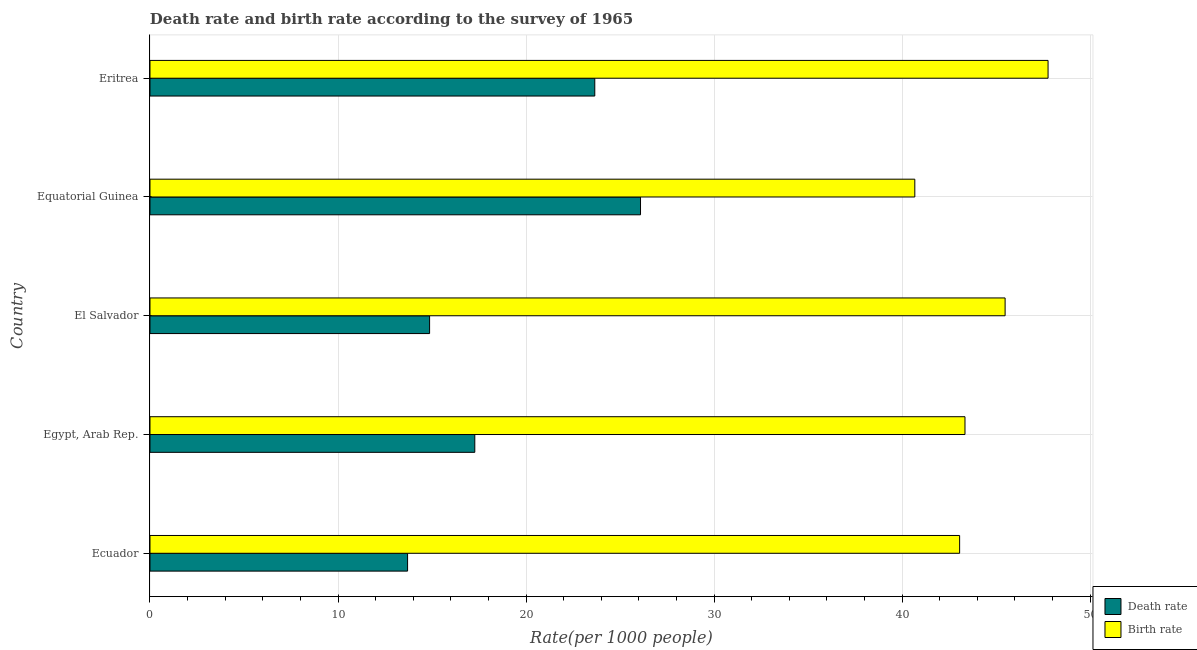What is the label of the 4th group of bars from the top?
Make the answer very short. Egypt, Arab Rep. In how many cases, is the number of bars for a given country not equal to the number of legend labels?
Make the answer very short. 0. What is the birth rate in Ecuador?
Keep it short and to the point. 43.06. Across all countries, what is the maximum death rate?
Make the answer very short. 26.09. Across all countries, what is the minimum death rate?
Your answer should be compact. 13.7. In which country was the birth rate maximum?
Ensure brevity in your answer.  Eritrea. In which country was the death rate minimum?
Offer a very short reply. Ecuador. What is the total death rate in the graph?
Provide a short and direct response. 95.59. What is the difference between the birth rate in Egypt, Arab Rep. and that in Eritrea?
Your response must be concise. -4.42. What is the difference between the birth rate in Ecuador and the death rate in Eritrea?
Your response must be concise. 19.4. What is the average death rate per country?
Ensure brevity in your answer.  19.12. What is the difference between the birth rate and death rate in El Salvador?
Offer a terse response. 30.61. In how many countries, is the death rate greater than 40 ?
Offer a very short reply. 0. What is the ratio of the birth rate in Equatorial Guinea to that in Eritrea?
Your response must be concise. 0.85. What is the difference between the highest and the second highest birth rate?
Your response must be concise. 2.28. What is the difference between the highest and the lowest death rate?
Offer a very short reply. 12.39. In how many countries, is the birth rate greater than the average birth rate taken over all countries?
Your response must be concise. 2. Is the sum of the birth rate in Ecuador and Egypt, Arab Rep. greater than the maximum death rate across all countries?
Provide a succinct answer. Yes. What does the 2nd bar from the top in Equatorial Guinea represents?
Provide a short and direct response. Death rate. What does the 2nd bar from the bottom in El Salvador represents?
Provide a succinct answer. Birth rate. Are all the bars in the graph horizontal?
Offer a very short reply. Yes. How many legend labels are there?
Offer a very short reply. 2. How are the legend labels stacked?
Ensure brevity in your answer.  Vertical. What is the title of the graph?
Your answer should be very brief. Death rate and birth rate according to the survey of 1965. What is the label or title of the X-axis?
Your answer should be compact. Rate(per 1000 people). What is the label or title of the Y-axis?
Make the answer very short. Country. What is the Rate(per 1000 people) in Birth rate in Ecuador?
Provide a short and direct response. 43.06. What is the Rate(per 1000 people) in Death rate in Egypt, Arab Rep.?
Keep it short and to the point. 17.27. What is the Rate(per 1000 people) of Birth rate in Egypt, Arab Rep.?
Make the answer very short. 43.35. What is the Rate(per 1000 people) of Death rate in El Salvador?
Ensure brevity in your answer.  14.87. What is the Rate(per 1000 people) in Birth rate in El Salvador?
Provide a succinct answer. 45.48. What is the Rate(per 1000 people) of Death rate in Equatorial Guinea?
Keep it short and to the point. 26.09. What is the Rate(per 1000 people) of Birth rate in Equatorial Guinea?
Your answer should be compact. 40.68. What is the Rate(per 1000 people) of Death rate in Eritrea?
Offer a terse response. 23.66. What is the Rate(per 1000 people) in Birth rate in Eritrea?
Your answer should be very brief. 47.77. Across all countries, what is the maximum Rate(per 1000 people) of Death rate?
Provide a short and direct response. 26.09. Across all countries, what is the maximum Rate(per 1000 people) of Birth rate?
Your answer should be compact. 47.77. Across all countries, what is the minimum Rate(per 1000 people) of Birth rate?
Keep it short and to the point. 40.68. What is the total Rate(per 1000 people) in Death rate in the graph?
Make the answer very short. 95.59. What is the total Rate(per 1000 people) in Birth rate in the graph?
Your answer should be very brief. 220.33. What is the difference between the Rate(per 1000 people) of Death rate in Ecuador and that in Egypt, Arab Rep.?
Ensure brevity in your answer.  -3.58. What is the difference between the Rate(per 1000 people) in Birth rate in Ecuador and that in Egypt, Arab Rep.?
Your answer should be very brief. -0.28. What is the difference between the Rate(per 1000 people) of Death rate in Ecuador and that in El Salvador?
Provide a short and direct response. -1.17. What is the difference between the Rate(per 1000 people) of Birth rate in Ecuador and that in El Salvador?
Give a very brief answer. -2.42. What is the difference between the Rate(per 1000 people) of Death rate in Ecuador and that in Equatorial Guinea?
Offer a very short reply. -12.39. What is the difference between the Rate(per 1000 people) in Birth rate in Ecuador and that in Equatorial Guinea?
Make the answer very short. 2.38. What is the difference between the Rate(per 1000 people) of Death rate in Ecuador and that in Eritrea?
Provide a succinct answer. -9.96. What is the difference between the Rate(per 1000 people) in Birth rate in Ecuador and that in Eritrea?
Ensure brevity in your answer.  -4.7. What is the difference between the Rate(per 1000 people) in Death rate in Egypt, Arab Rep. and that in El Salvador?
Keep it short and to the point. 2.4. What is the difference between the Rate(per 1000 people) of Birth rate in Egypt, Arab Rep. and that in El Salvador?
Make the answer very short. -2.13. What is the difference between the Rate(per 1000 people) in Death rate in Egypt, Arab Rep. and that in Equatorial Guinea?
Offer a terse response. -8.81. What is the difference between the Rate(per 1000 people) of Birth rate in Egypt, Arab Rep. and that in Equatorial Guinea?
Your response must be concise. 2.67. What is the difference between the Rate(per 1000 people) in Death rate in Egypt, Arab Rep. and that in Eritrea?
Offer a very short reply. -6.38. What is the difference between the Rate(per 1000 people) of Birth rate in Egypt, Arab Rep. and that in Eritrea?
Make the answer very short. -4.42. What is the difference between the Rate(per 1000 people) of Death rate in El Salvador and that in Equatorial Guinea?
Make the answer very short. -11.22. What is the difference between the Rate(per 1000 people) in Birth rate in El Salvador and that in Equatorial Guinea?
Keep it short and to the point. 4.8. What is the difference between the Rate(per 1000 people) in Death rate in El Salvador and that in Eritrea?
Make the answer very short. -8.79. What is the difference between the Rate(per 1000 people) of Birth rate in El Salvador and that in Eritrea?
Make the answer very short. -2.28. What is the difference between the Rate(per 1000 people) of Death rate in Equatorial Guinea and that in Eritrea?
Keep it short and to the point. 2.43. What is the difference between the Rate(per 1000 people) of Birth rate in Equatorial Guinea and that in Eritrea?
Provide a succinct answer. -7.09. What is the difference between the Rate(per 1000 people) in Death rate in Ecuador and the Rate(per 1000 people) in Birth rate in Egypt, Arab Rep.?
Provide a short and direct response. -29.65. What is the difference between the Rate(per 1000 people) in Death rate in Ecuador and the Rate(per 1000 people) in Birth rate in El Salvador?
Ensure brevity in your answer.  -31.78. What is the difference between the Rate(per 1000 people) of Death rate in Ecuador and the Rate(per 1000 people) of Birth rate in Equatorial Guinea?
Keep it short and to the point. -26.98. What is the difference between the Rate(per 1000 people) of Death rate in Ecuador and the Rate(per 1000 people) of Birth rate in Eritrea?
Give a very brief answer. -34.06. What is the difference between the Rate(per 1000 people) of Death rate in Egypt, Arab Rep. and the Rate(per 1000 people) of Birth rate in El Salvador?
Ensure brevity in your answer.  -28.21. What is the difference between the Rate(per 1000 people) of Death rate in Egypt, Arab Rep. and the Rate(per 1000 people) of Birth rate in Equatorial Guinea?
Give a very brief answer. -23.4. What is the difference between the Rate(per 1000 people) in Death rate in Egypt, Arab Rep. and the Rate(per 1000 people) in Birth rate in Eritrea?
Provide a short and direct response. -30.49. What is the difference between the Rate(per 1000 people) in Death rate in El Salvador and the Rate(per 1000 people) in Birth rate in Equatorial Guinea?
Make the answer very short. -25.81. What is the difference between the Rate(per 1000 people) in Death rate in El Salvador and the Rate(per 1000 people) in Birth rate in Eritrea?
Provide a short and direct response. -32.89. What is the difference between the Rate(per 1000 people) in Death rate in Equatorial Guinea and the Rate(per 1000 people) in Birth rate in Eritrea?
Give a very brief answer. -21.68. What is the average Rate(per 1000 people) in Death rate per country?
Provide a short and direct response. 19.12. What is the average Rate(per 1000 people) in Birth rate per country?
Make the answer very short. 44.07. What is the difference between the Rate(per 1000 people) of Death rate and Rate(per 1000 people) of Birth rate in Ecuador?
Ensure brevity in your answer.  -29.36. What is the difference between the Rate(per 1000 people) of Death rate and Rate(per 1000 people) of Birth rate in Egypt, Arab Rep.?
Your answer should be very brief. -26.07. What is the difference between the Rate(per 1000 people) of Death rate and Rate(per 1000 people) of Birth rate in El Salvador?
Make the answer very short. -30.61. What is the difference between the Rate(per 1000 people) of Death rate and Rate(per 1000 people) of Birth rate in Equatorial Guinea?
Provide a succinct answer. -14.59. What is the difference between the Rate(per 1000 people) in Death rate and Rate(per 1000 people) in Birth rate in Eritrea?
Provide a succinct answer. -24.11. What is the ratio of the Rate(per 1000 people) in Death rate in Ecuador to that in Egypt, Arab Rep.?
Offer a terse response. 0.79. What is the ratio of the Rate(per 1000 people) in Death rate in Ecuador to that in El Salvador?
Your answer should be compact. 0.92. What is the ratio of the Rate(per 1000 people) in Birth rate in Ecuador to that in El Salvador?
Make the answer very short. 0.95. What is the ratio of the Rate(per 1000 people) in Death rate in Ecuador to that in Equatorial Guinea?
Offer a very short reply. 0.53. What is the ratio of the Rate(per 1000 people) of Birth rate in Ecuador to that in Equatorial Guinea?
Give a very brief answer. 1.06. What is the ratio of the Rate(per 1000 people) in Death rate in Ecuador to that in Eritrea?
Provide a short and direct response. 0.58. What is the ratio of the Rate(per 1000 people) in Birth rate in Ecuador to that in Eritrea?
Offer a very short reply. 0.9. What is the ratio of the Rate(per 1000 people) in Death rate in Egypt, Arab Rep. to that in El Salvador?
Provide a short and direct response. 1.16. What is the ratio of the Rate(per 1000 people) in Birth rate in Egypt, Arab Rep. to that in El Salvador?
Your response must be concise. 0.95. What is the ratio of the Rate(per 1000 people) of Death rate in Egypt, Arab Rep. to that in Equatorial Guinea?
Offer a very short reply. 0.66. What is the ratio of the Rate(per 1000 people) in Birth rate in Egypt, Arab Rep. to that in Equatorial Guinea?
Offer a terse response. 1.07. What is the ratio of the Rate(per 1000 people) of Death rate in Egypt, Arab Rep. to that in Eritrea?
Provide a short and direct response. 0.73. What is the ratio of the Rate(per 1000 people) in Birth rate in Egypt, Arab Rep. to that in Eritrea?
Your response must be concise. 0.91. What is the ratio of the Rate(per 1000 people) in Death rate in El Salvador to that in Equatorial Guinea?
Your response must be concise. 0.57. What is the ratio of the Rate(per 1000 people) in Birth rate in El Salvador to that in Equatorial Guinea?
Your answer should be very brief. 1.12. What is the ratio of the Rate(per 1000 people) of Death rate in El Salvador to that in Eritrea?
Provide a succinct answer. 0.63. What is the ratio of the Rate(per 1000 people) of Birth rate in El Salvador to that in Eritrea?
Offer a very short reply. 0.95. What is the ratio of the Rate(per 1000 people) in Death rate in Equatorial Guinea to that in Eritrea?
Offer a terse response. 1.1. What is the ratio of the Rate(per 1000 people) in Birth rate in Equatorial Guinea to that in Eritrea?
Your answer should be compact. 0.85. What is the difference between the highest and the second highest Rate(per 1000 people) in Death rate?
Provide a succinct answer. 2.43. What is the difference between the highest and the second highest Rate(per 1000 people) in Birth rate?
Your answer should be compact. 2.28. What is the difference between the highest and the lowest Rate(per 1000 people) of Death rate?
Your answer should be very brief. 12.39. What is the difference between the highest and the lowest Rate(per 1000 people) in Birth rate?
Keep it short and to the point. 7.09. 